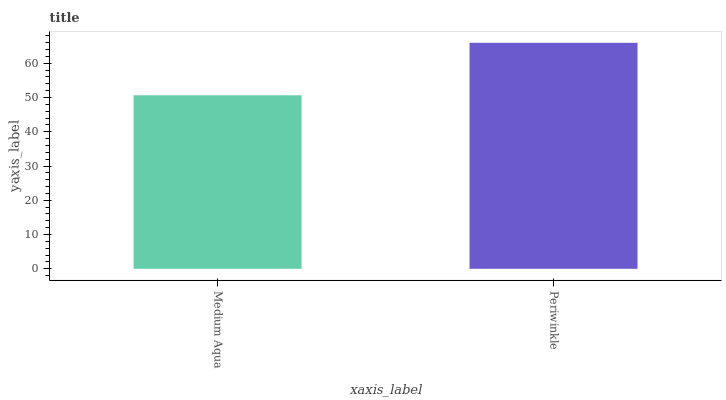Is Medium Aqua the minimum?
Answer yes or no. Yes. Is Periwinkle the maximum?
Answer yes or no. Yes. Is Periwinkle the minimum?
Answer yes or no. No. Is Periwinkle greater than Medium Aqua?
Answer yes or no. Yes. Is Medium Aqua less than Periwinkle?
Answer yes or no. Yes. Is Medium Aqua greater than Periwinkle?
Answer yes or no. No. Is Periwinkle less than Medium Aqua?
Answer yes or no. No. Is Periwinkle the high median?
Answer yes or no. Yes. Is Medium Aqua the low median?
Answer yes or no. Yes. Is Medium Aqua the high median?
Answer yes or no. No. Is Periwinkle the low median?
Answer yes or no. No. 